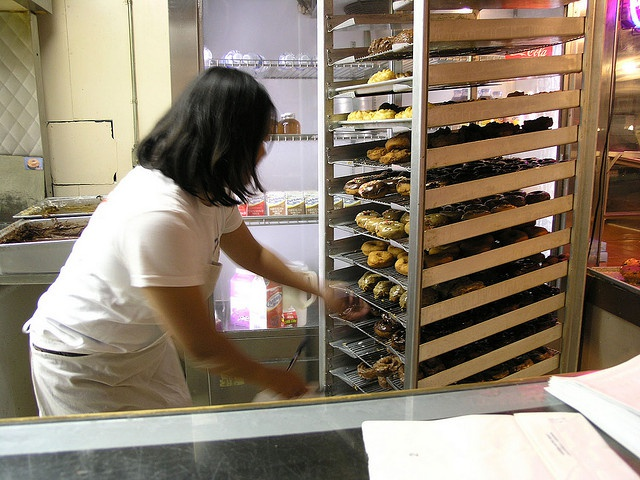Describe the objects in this image and their specific colors. I can see people in olive, white, black, gray, and maroon tones, refrigerator in olive, lavender, darkgray, and gray tones, donut in olive, black, and tan tones, donut in olive, black, maroon, khaki, and white tones, and donut in olive, black, maroon, and orange tones in this image. 